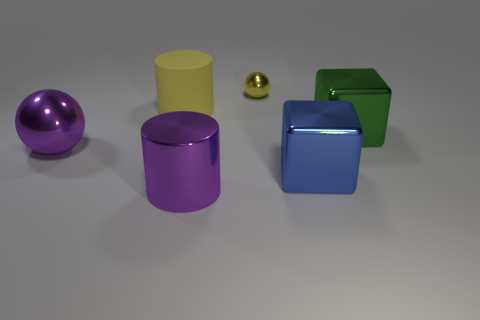Subtract 1 yellow cylinders. How many objects are left? 5 Subtract all spheres. How many objects are left? 4 Subtract 1 blocks. How many blocks are left? 1 Subtract all green cylinders. Subtract all purple blocks. How many cylinders are left? 2 Subtract all brown cubes. How many gray spheres are left? 0 Subtract all purple cylinders. Subtract all metal balls. How many objects are left? 3 Add 2 green shiny objects. How many green shiny objects are left? 3 Add 3 yellow spheres. How many yellow spheres exist? 4 Add 1 big purple shiny spheres. How many objects exist? 7 Subtract all yellow balls. How many balls are left? 1 